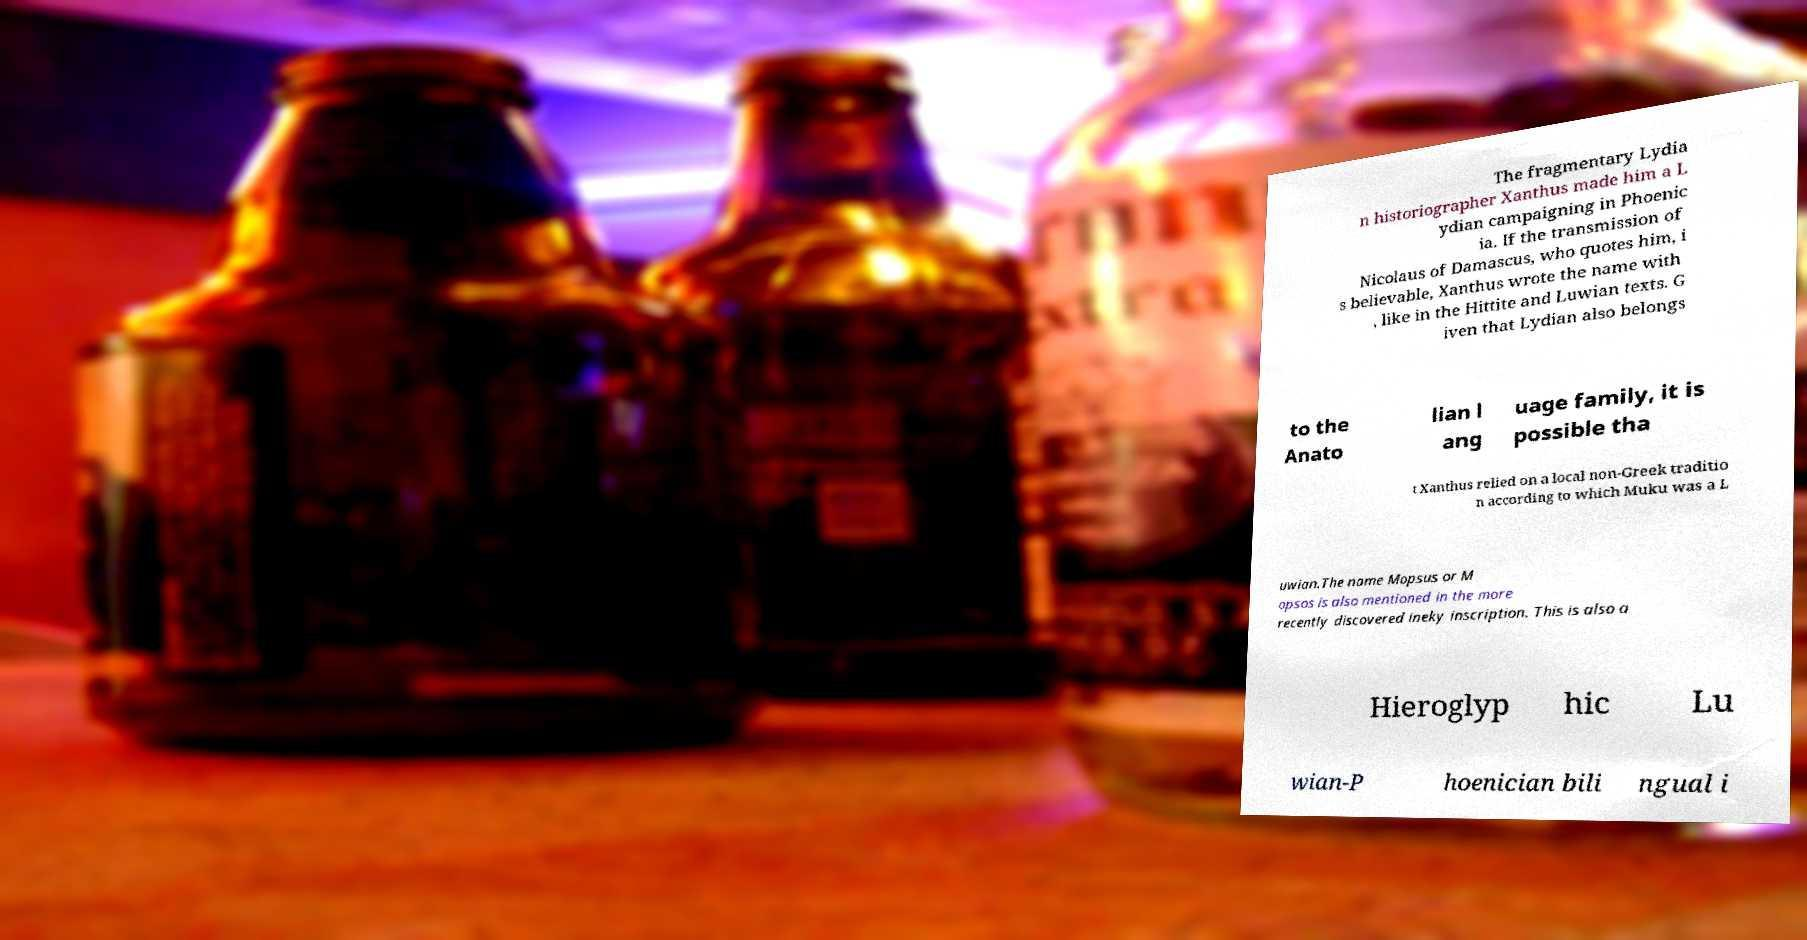What messages or text are displayed in this image? I need them in a readable, typed format. The fragmentary Lydia n historiographer Xanthus made him a L ydian campaigning in Phoenic ia. If the transmission of Nicolaus of Damascus, who quotes him, i s believable, Xanthus wrote the name with , like in the Hittite and Luwian texts. G iven that Lydian also belongs to the Anato lian l ang uage family, it is possible tha t Xanthus relied on a local non-Greek traditio n according to which Muku was a L uwian.The name Mopsus or M opsos is also mentioned in the more recently discovered ineky inscription. This is also a Hieroglyp hic Lu wian-P hoenician bili ngual i 